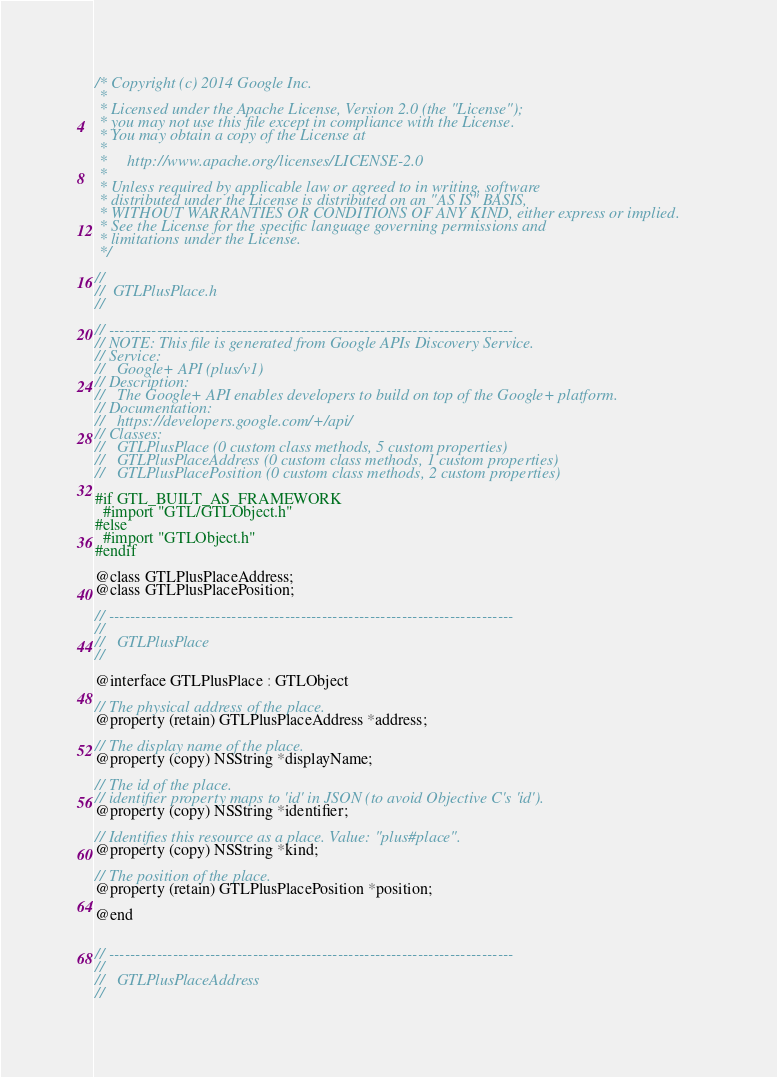Convert code to text. <code><loc_0><loc_0><loc_500><loc_500><_C_>/* Copyright (c) 2014 Google Inc.
 *
 * Licensed under the Apache License, Version 2.0 (the "License");
 * you may not use this file except in compliance with the License.
 * You may obtain a copy of the License at
 *
 *     http://www.apache.org/licenses/LICENSE-2.0
 *
 * Unless required by applicable law or agreed to in writing, software
 * distributed under the License is distributed on an "AS IS" BASIS,
 * WITHOUT WARRANTIES OR CONDITIONS OF ANY KIND, either express or implied.
 * See the License for the specific language governing permissions and
 * limitations under the License.
 */

//
//  GTLPlusPlace.h
//

// ----------------------------------------------------------------------------
// NOTE: This file is generated from Google APIs Discovery Service.
// Service:
//   Google+ API (plus/v1)
// Description:
//   The Google+ API enables developers to build on top of the Google+ platform.
// Documentation:
//   https://developers.google.com/+/api/
// Classes:
//   GTLPlusPlace (0 custom class methods, 5 custom properties)
//   GTLPlusPlaceAddress (0 custom class methods, 1 custom properties)
//   GTLPlusPlacePosition (0 custom class methods, 2 custom properties)

#if GTL_BUILT_AS_FRAMEWORK
  #import "GTL/GTLObject.h"
#else
  #import "GTLObject.h"
#endif

@class GTLPlusPlaceAddress;
@class GTLPlusPlacePosition;

// ----------------------------------------------------------------------------
//
//   GTLPlusPlace
//

@interface GTLPlusPlace : GTLObject

// The physical address of the place.
@property (retain) GTLPlusPlaceAddress *address;

// The display name of the place.
@property (copy) NSString *displayName;

// The id of the place.
// identifier property maps to 'id' in JSON (to avoid Objective C's 'id').
@property (copy) NSString *identifier;

// Identifies this resource as a place. Value: "plus#place".
@property (copy) NSString *kind;

// The position of the place.
@property (retain) GTLPlusPlacePosition *position;

@end


// ----------------------------------------------------------------------------
//
//   GTLPlusPlaceAddress
//
</code> 